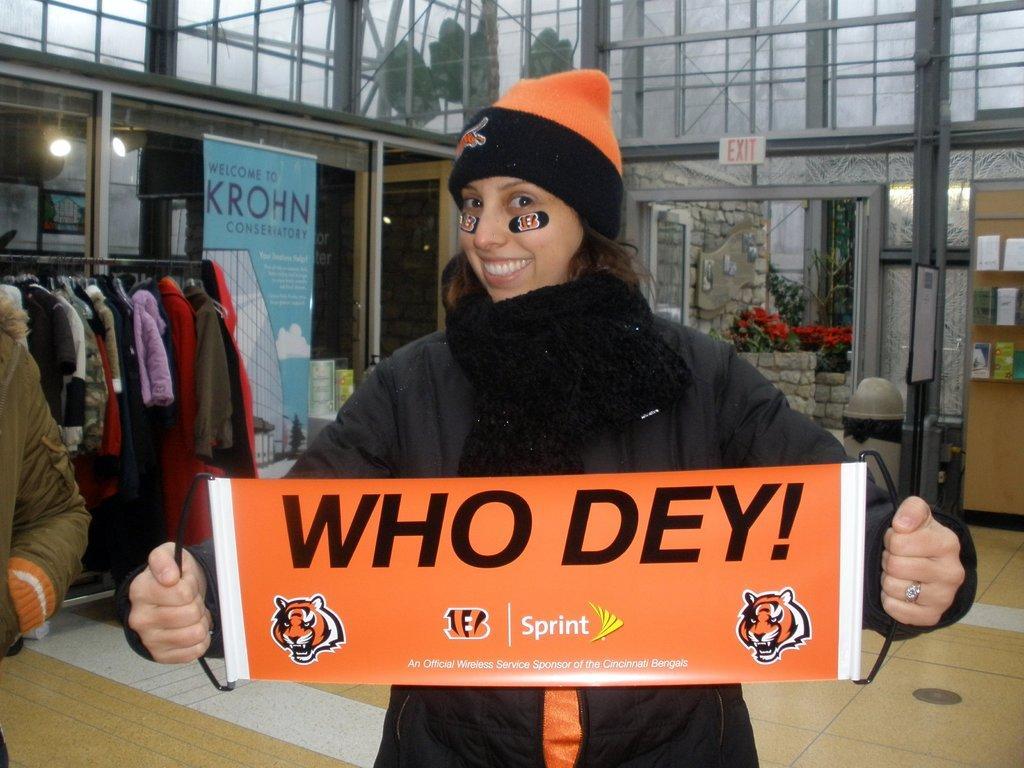Can you describe this image briefly? In this picture I can observe a woman wearing a cap on her head. The woman is smiling. She is holding an orange color poster in her hands. I can observe some text on the poster. On the left side there are some hoodies and clothes hanged to the hangers. In the background I can observe blue color poster. 